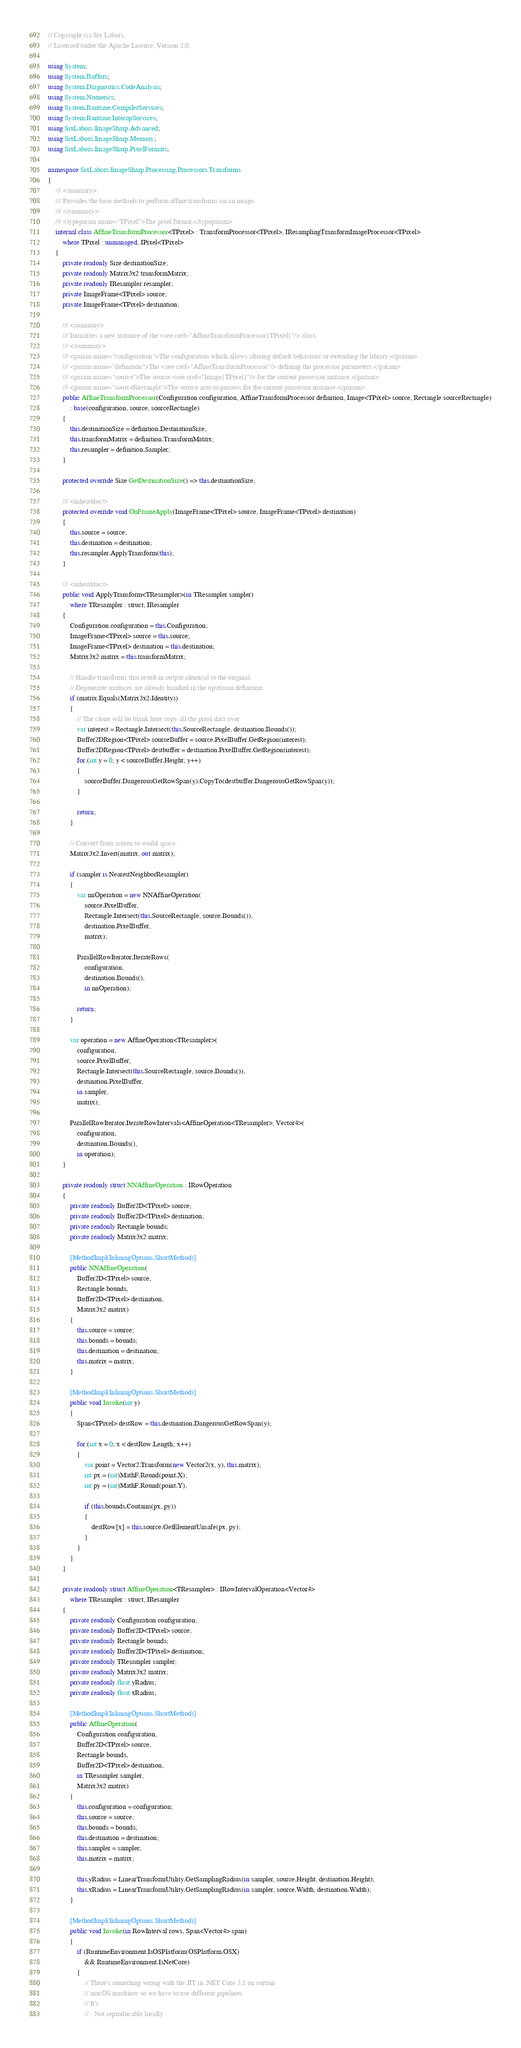Convert code to text. <code><loc_0><loc_0><loc_500><loc_500><_C#_>// Copyright (c) Six Labors.
// Licensed under the Apache License, Version 2.0.

using System;
using System.Buffers;
using System.Diagnostics.CodeAnalysis;
using System.Numerics;
using System.Runtime.CompilerServices;
using System.Runtime.InteropServices;
using SixLabors.ImageSharp.Advanced;
using SixLabors.ImageSharp.Memory;
using SixLabors.ImageSharp.PixelFormats;

namespace SixLabors.ImageSharp.Processing.Processors.Transforms
{
    /// <summary>
    /// Provides the base methods to perform affine transforms on an image.
    /// </summary>
    /// <typeparam name="TPixel">The pixel format.</typeparam>
    internal class AffineTransformProcessor<TPixel> : TransformProcessor<TPixel>, IResamplingTransformImageProcessor<TPixel>
        where TPixel : unmanaged, IPixel<TPixel>
    {
        private readonly Size destinationSize;
        private readonly Matrix3x2 transformMatrix;
        private readonly IResampler resampler;
        private ImageFrame<TPixel> source;
        private ImageFrame<TPixel> destination;

        /// <summary>
        /// Initializes a new instance of the <see cref="AffineTransformProcessor{TPixel}"/> class.
        /// </summary>
        /// <param name="configuration">The configuration which allows altering default behaviour or extending the library.</param>
        /// <param name="definition">The <see cref="AffineTransformProcessor"/> defining the processor parameters.</param>
        /// <param name="source">The source <see cref="Image{TPixel}"/> for the current processor instance.</param>
        /// <param name="sourceRectangle">The source area to process for the current processor instance.</param>
        public AffineTransformProcessor(Configuration configuration, AffineTransformProcessor definition, Image<TPixel> source, Rectangle sourceRectangle)
            : base(configuration, source, sourceRectangle)
        {
            this.destinationSize = definition.DestinationSize;
            this.transformMatrix = definition.TransformMatrix;
            this.resampler = definition.Sampler;
        }

        protected override Size GetDestinationSize() => this.destinationSize;

        /// <inheritdoc/>
        protected override void OnFrameApply(ImageFrame<TPixel> source, ImageFrame<TPixel> destination)
        {
            this.source = source;
            this.destination = destination;
            this.resampler.ApplyTransform(this);
        }

        /// <inheritdoc/>
        public void ApplyTransform<TResampler>(in TResampler sampler)
            where TResampler : struct, IResampler
        {
            Configuration configuration = this.Configuration;
            ImageFrame<TPixel> source = this.source;
            ImageFrame<TPixel> destination = this.destination;
            Matrix3x2 matrix = this.transformMatrix;

            // Handle transforms that result in output identical to the original.
            // Degenerate matrices are already handled in the upstream definition.
            if (matrix.Equals(Matrix3x2.Identity))
            {
                // The clone will be blank here copy all the pixel data over
                var interest = Rectangle.Intersect(this.SourceRectangle, destination.Bounds());
                Buffer2DRegion<TPixel> sourceBuffer = source.PixelBuffer.GetRegion(interest);
                Buffer2DRegion<TPixel> destbuffer = destination.PixelBuffer.GetRegion(interest);
                for (int y = 0; y < sourceBuffer.Height; y++)
                {
                    sourceBuffer.DangerousGetRowSpan(y).CopyTo(destbuffer.DangerousGetRowSpan(y));
                }

                return;
            }

            // Convert from screen to world space.
            Matrix3x2.Invert(matrix, out matrix);

            if (sampler is NearestNeighborResampler)
            {
                var nnOperation = new NNAffineOperation(
                    source.PixelBuffer,
                    Rectangle.Intersect(this.SourceRectangle, source.Bounds()),
                    destination.PixelBuffer,
                    matrix);

                ParallelRowIterator.IterateRows(
                    configuration,
                    destination.Bounds(),
                    in nnOperation);

                return;
            }

            var operation = new AffineOperation<TResampler>(
                configuration,
                source.PixelBuffer,
                Rectangle.Intersect(this.SourceRectangle, source.Bounds()),
                destination.PixelBuffer,
                in sampler,
                matrix);

            ParallelRowIterator.IterateRowIntervals<AffineOperation<TResampler>, Vector4>(
                configuration,
                destination.Bounds(),
                in operation);
        }

        private readonly struct NNAffineOperation : IRowOperation
        {
            private readonly Buffer2D<TPixel> source;
            private readonly Buffer2D<TPixel> destination;
            private readonly Rectangle bounds;
            private readonly Matrix3x2 matrix;

            [MethodImpl(InliningOptions.ShortMethod)]
            public NNAffineOperation(
                Buffer2D<TPixel> source,
                Rectangle bounds,
                Buffer2D<TPixel> destination,
                Matrix3x2 matrix)
            {
                this.source = source;
                this.bounds = bounds;
                this.destination = destination;
                this.matrix = matrix;
            }

            [MethodImpl(InliningOptions.ShortMethod)]
            public void Invoke(int y)
            {
                Span<TPixel> destRow = this.destination.DangerousGetRowSpan(y);

                for (int x = 0; x < destRow.Length; x++)
                {
                    var point = Vector2.Transform(new Vector2(x, y), this.matrix);
                    int px = (int)MathF.Round(point.X);
                    int py = (int)MathF.Round(point.Y);

                    if (this.bounds.Contains(px, py))
                    {
                        destRow[x] = this.source.GetElementUnsafe(px, py);
                    }
                }
            }
        }

        private readonly struct AffineOperation<TResampler> : IRowIntervalOperation<Vector4>
            where TResampler : struct, IResampler
        {
            private readonly Configuration configuration;
            private readonly Buffer2D<TPixel> source;
            private readonly Rectangle bounds;
            private readonly Buffer2D<TPixel> destination;
            private readonly TResampler sampler;
            private readonly Matrix3x2 matrix;
            private readonly float yRadius;
            private readonly float xRadius;

            [MethodImpl(InliningOptions.ShortMethod)]
            public AffineOperation(
                Configuration configuration,
                Buffer2D<TPixel> source,
                Rectangle bounds,
                Buffer2D<TPixel> destination,
                in TResampler sampler,
                Matrix3x2 matrix)
            {
                this.configuration = configuration;
                this.source = source;
                this.bounds = bounds;
                this.destination = destination;
                this.sampler = sampler;
                this.matrix = matrix;

                this.yRadius = LinearTransformUtility.GetSamplingRadius(in sampler, source.Height, destination.Height);
                this.xRadius = LinearTransformUtility.GetSamplingRadius(in sampler, source.Width, destination.Width);
            }

            [MethodImpl(InliningOptions.ShortMethod)]
            public void Invoke(in RowInterval rows, Span<Vector4> span)
            {
                if (RuntimeEnvironment.IsOSPlatform(OSPlatform.OSX)
                    && RuntimeEnvironment.IsNetCore)
                {
                    // There's something wrong with the JIT in .NET Core 3.1 on certain
                    // macOS machines so we have to use different pipelines.
                    // It's:
                    // - Not reproducable locally</code> 